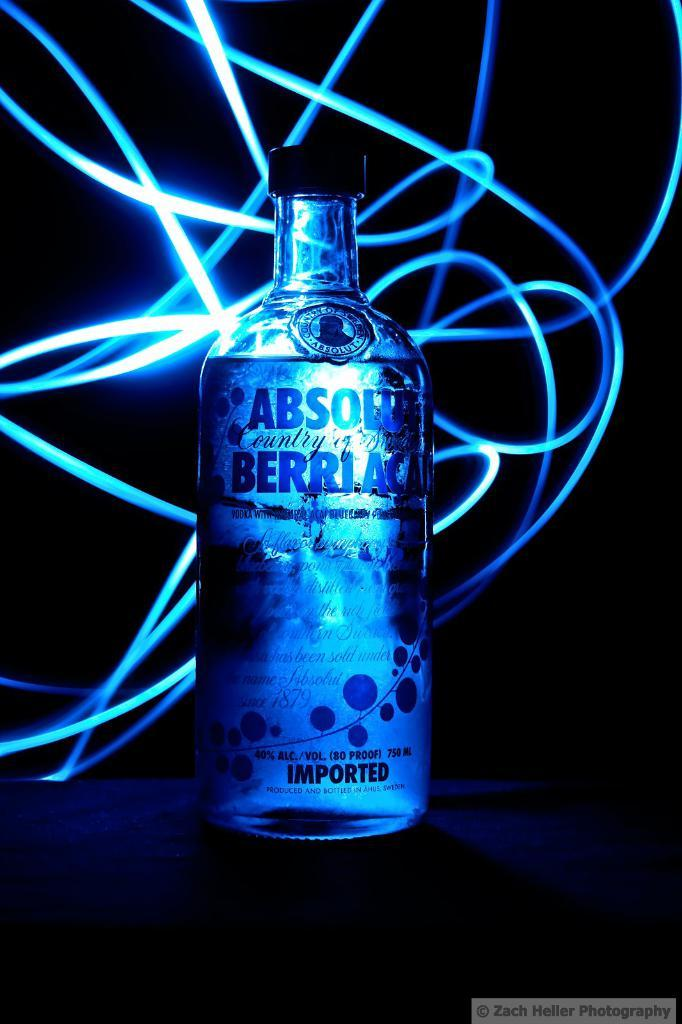<image>
Render a clear and concise summary of the photo. A bottle of absolute berry vodka with lights swirling around it. 